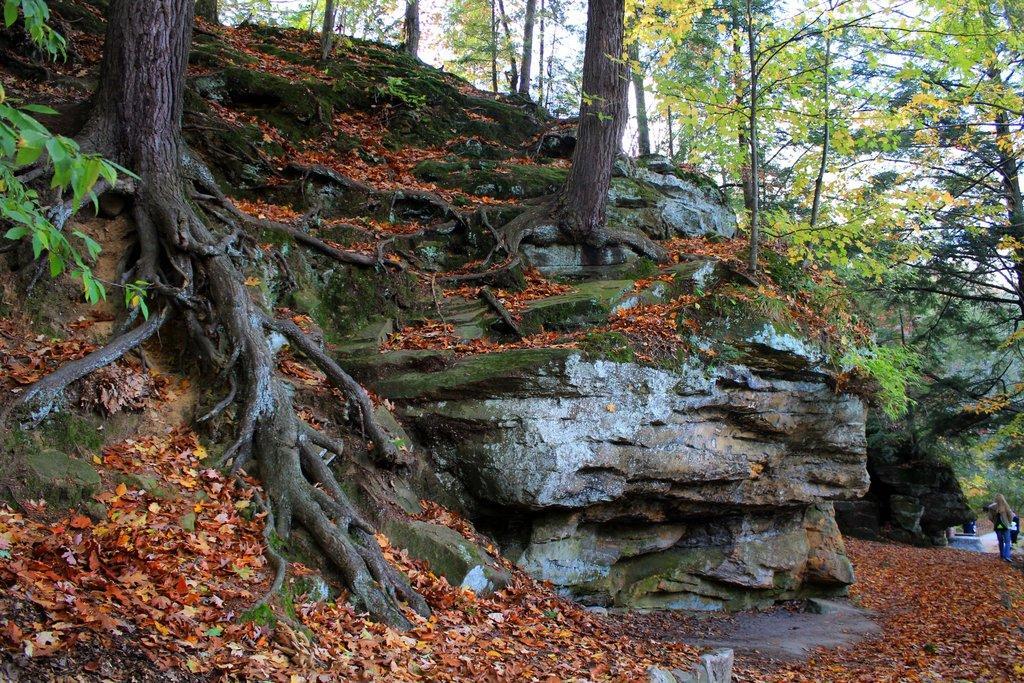Can you describe this image briefly? In this picture we can see some dry leaves on the path, There are a few tree trunks and plants on the right and left side of the image. We can see two people on the right side. There are a few trees visible in the background. 